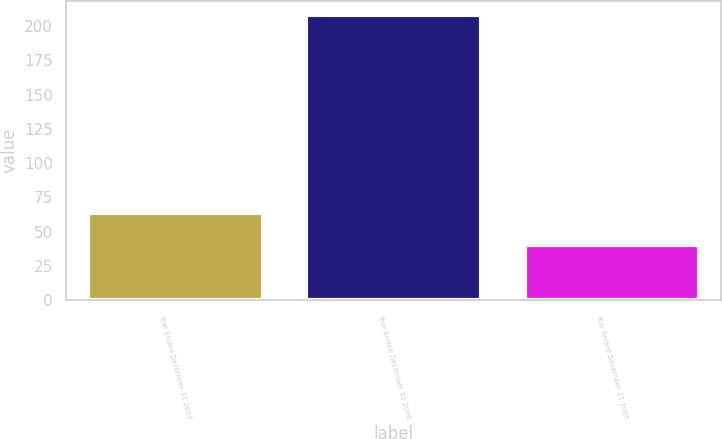<chart> <loc_0><loc_0><loc_500><loc_500><bar_chart><fcel>Year Ended December 31 2007<fcel>Year Ended December 31 2006<fcel>Year Ended December 31 2005<nl><fcel>64<fcel>208<fcel>40<nl></chart> 